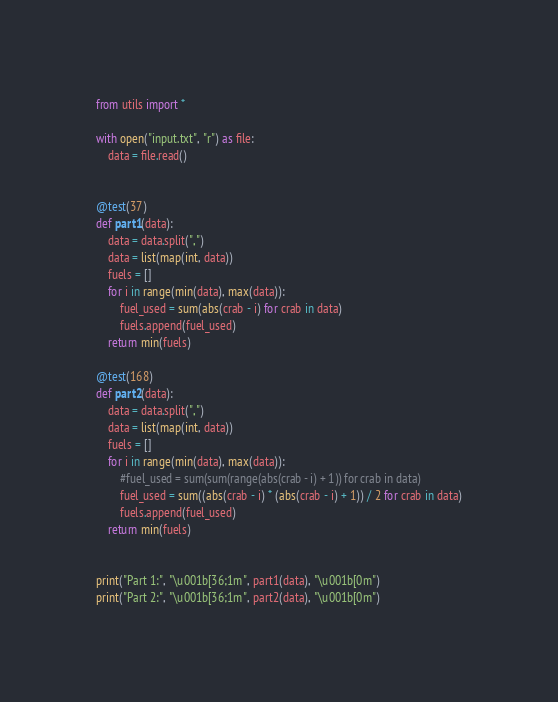<code> <loc_0><loc_0><loc_500><loc_500><_Python_>
from utils import *

with open("input.txt", "r") as file:
    data = file.read()


@test(37)
def part1(data):
    data = data.split(",")
    data = list(map(int, data))
    fuels = []
    for i in range(min(data), max(data)):
        fuel_used = sum(abs(crab - i) for crab in data)
        fuels.append(fuel_used)
    return min(fuels)

@test(168)
def part2(data):
    data = data.split(",")
    data = list(map(int, data))
    fuels = []
    for i in range(min(data), max(data)):
        #fuel_used = sum(sum(range(abs(crab - i) + 1)) for crab in data)
        fuel_used = sum((abs(crab - i) * (abs(crab - i) + 1)) / 2 for crab in data)
        fuels.append(fuel_used)
    return min(fuels)


print("Part 1:", "\u001b[36;1m", part1(data), "\u001b[0m")
print("Part 2:", "\u001b[36;1m", part2(data), "\u001b[0m")
</code> 